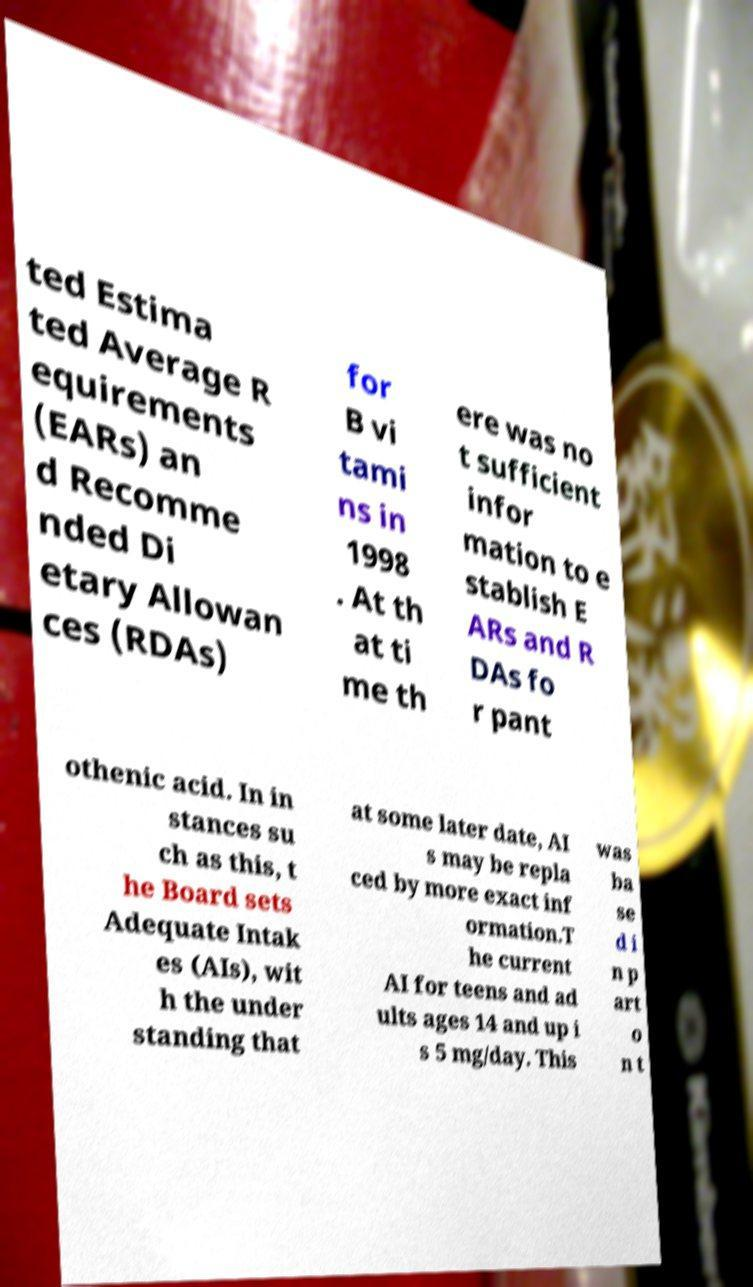What messages or text are displayed in this image? I need them in a readable, typed format. ted Estima ted Average R equirements (EARs) an d Recomme nded Di etary Allowan ces (RDAs) for B vi tami ns in 1998 . At th at ti me th ere was no t sufficient infor mation to e stablish E ARs and R DAs fo r pant othenic acid. In in stances su ch as this, t he Board sets Adequate Intak es (AIs), wit h the under standing that at some later date, AI s may be repla ced by more exact inf ormation.T he current AI for teens and ad ults ages 14 and up i s 5 mg/day. This was ba se d i n p art o n t 